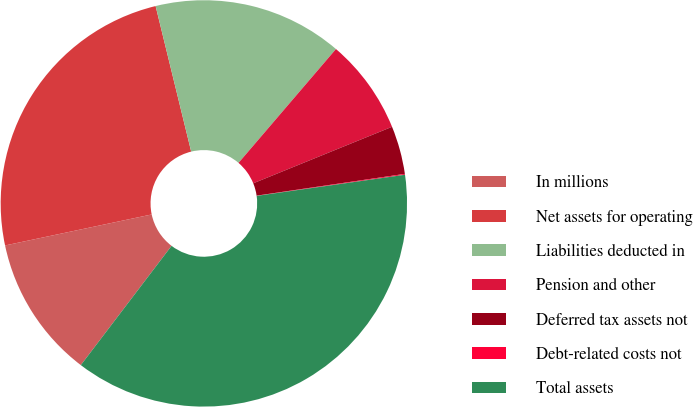Convert chart. <chart><loc_0><loc_0><loc_500><loc_500><pie_chart><fcel>In millions<fcel>Net assets for operating<fcel>Liabilities deducted in<fcel>Pension and other<fcel>Deferred tax assets not<fcel>Debt-related costs not<fcel>Total assets<nl><fcel>11.33%<fcel>24.5%<fcel>15.08%<fcel>7.58%<fcel>3.83%<fcel>0.07%<fcel>37.6%<nl></chart> 